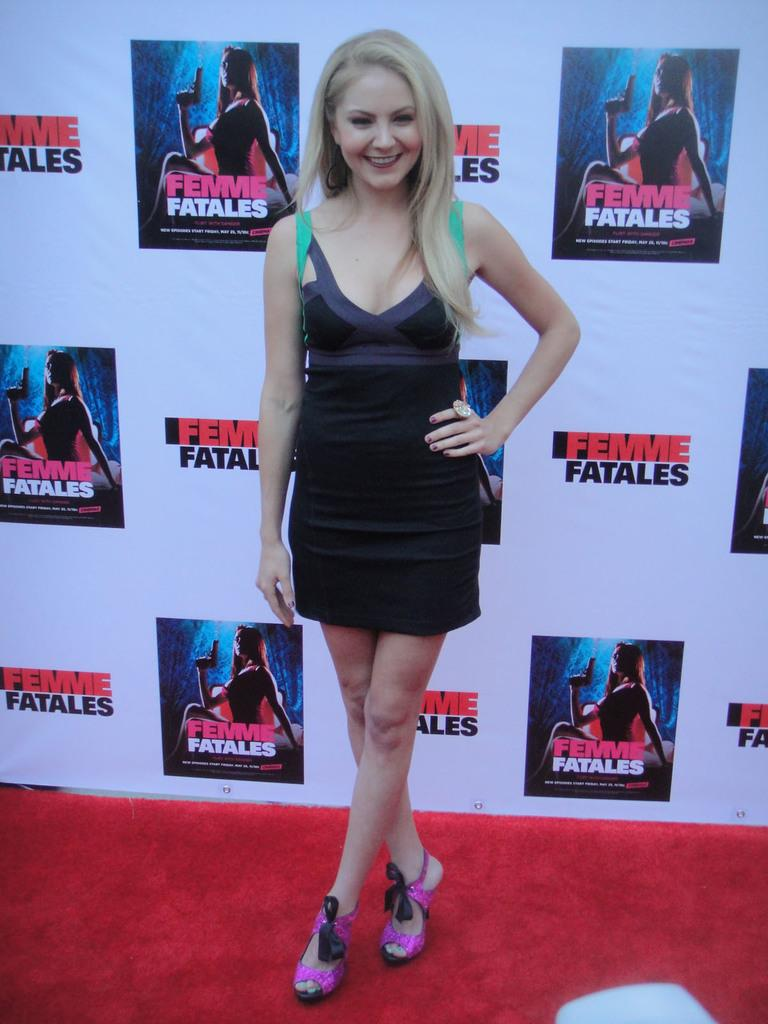Who is the main subject in the image? There is a woman in the image. What is the woman standing on? The woman is standing on a carpet. What else can be seen in the image besides the woman? There is a banner in the image. How far away are the clouds from the woman in the image? There are no clouds visible in the image, so it is not possible to determine their distance from the woman. 